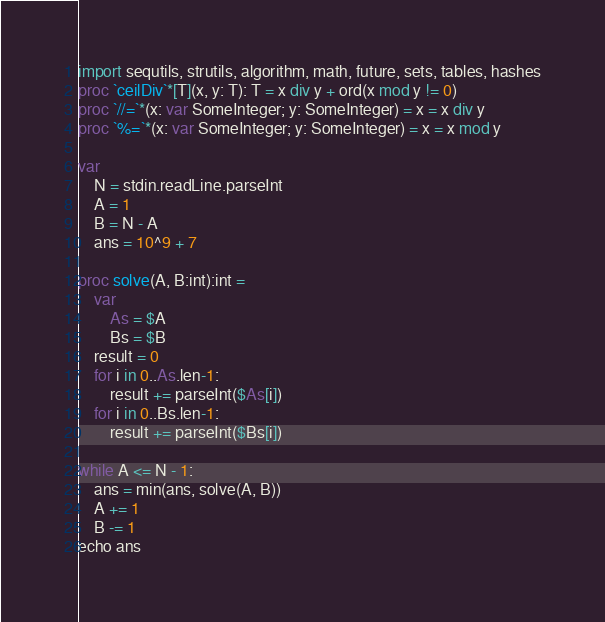Convert code to text. <code><loc_0><loc_0><loc_500><loc_500><_Nim_>import sequtils, strutils, algorithm, math, future, sets, tables, hashes
proc `ceilDiv`*[T](x, y: T): T = x div y + ord(x mod y != 0)
proc `//=`*(x: var SomeInteger; y: SomeInteger) = x = x div y
proc `%=`*(x: var SomeInteger; y: SomeInteger) = x = x mod y

var
    N = stdin.readLine.parseInt
    A = 1
    B = N - A
    ans = 10^9 + 7

proc solve(A, B:int):int =
    var
        As = $A
        Bs = $B
    result = 0
    for i in 0..As.len-1:
        result += parseInt($As[i])
    for i in 0..Bs.len-1:
        result += parseInt($Bs[i])

while A <= N - 1:
    ans = min(ans, solve(A, B))
    A += 1
    B -= 1
echo ans
</code> 